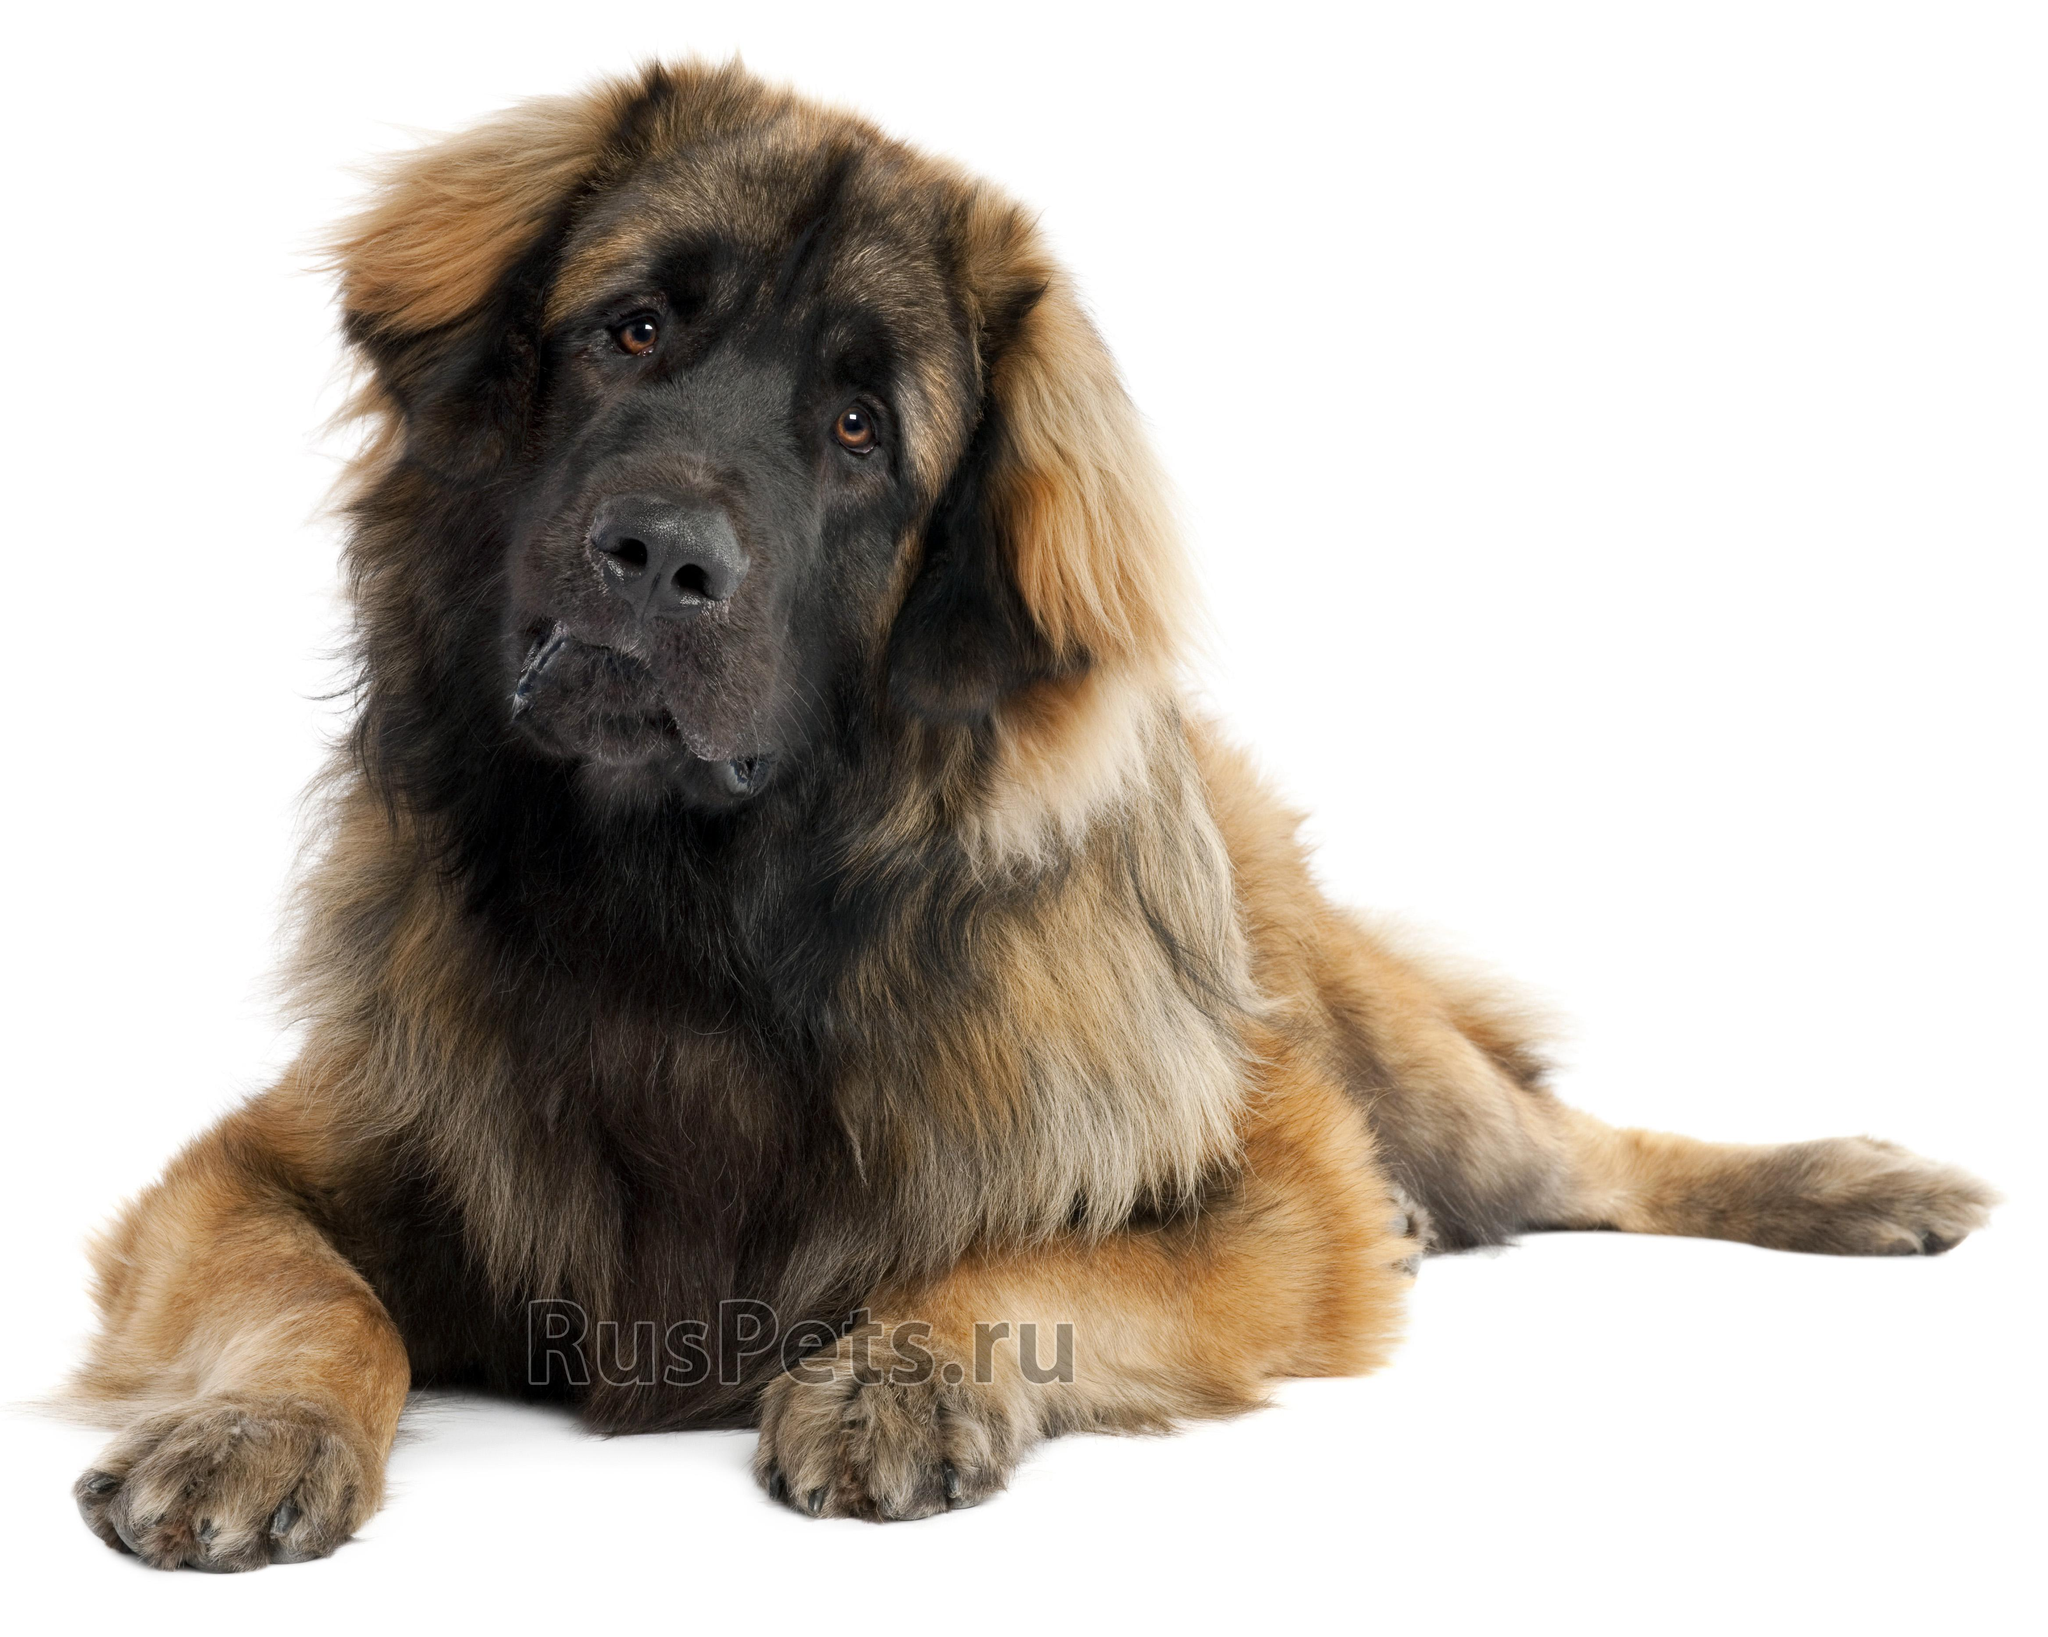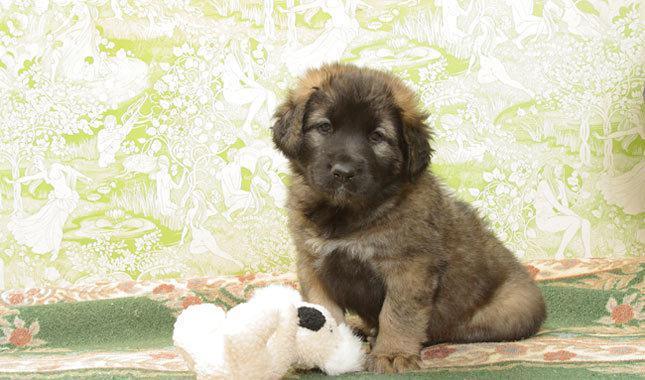The first image is the image on the left, the second image is the image on the right. For the images shown, is this caption "Some dogs are sitting on the ground." true? Answer yes or no. Yes. 